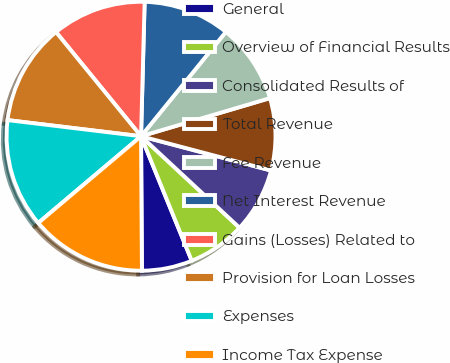Convert chart. <chart><loc_0><loc_0><loc_500><loc_500><pie_chart><fcel>General<fcel>Overview of Financial Results<fcel>Consolidated Results of<fcel>Total Revenue<fcel>Fee Revenue<fcel>Net Interest Revenue<fcel>Gains (Losses) Related to<fcel>Provision for Loan Losses<fcel>Expenses<fcel>Income Tax Expense<nl><fcel>6.05%<fcel>6.93%<fcel>7.81%<fcel>8.68%<fcel>9.56%<fcel>10.44%<fcel>11.32%<fcel>12.19%<fcel>13.07%<fcel>13.95%<nl></chart> 